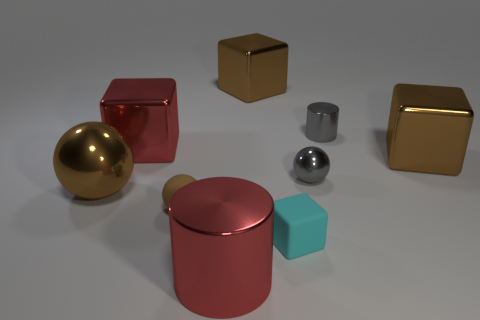How many small blocks are the same color as the big sphere?
Provide a short and direct response. 0. Is the color of the tiny metallic cylinder the same as the big metal ball?
Your answer should be compact. No. What material is the red cylinder that is in front of the tiny brown rubber ball?
Keep it short and to the point. Metal. How many small objects are either blue metal balls or red shiny blocks?
Your response must be concise. 0. There is another large sphere that is the same color as the matte sphere; what is its material?
Your answer should be very brief. Metal. Are there any green blocks that have the same material as the tiny cylinder?
Make the answer very short. No. Is the size of the cylinder that is on the left side of the cyan block the same as the red cube?
Provide a succinct answer. Yes. There is a red thing in front of the large brown shiny block in front of the tiny gray cylinder; is there a tiny gray shiny sphere to the left of it?
Provide a succinct answer. No. How many shiny objects are big cylinders or red objects?
Offer a very short reply. 2. How many other objects are there of the same shape as the brown rubber object?
Your answer should be very brief. 2. 